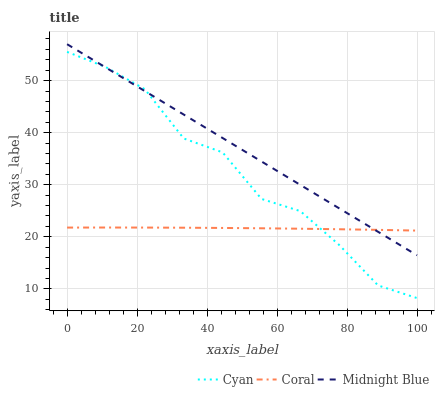Does Coral have the minimum area under the curve?
Answer yes or no. Yes. Does Midnight Blue have the maximum area under the curve?
Answer yes or no. Yes. Does Midnight Blue have the minimum area under the curve?
Answer yes or no. No. Does Coral have the maximum area under the curve?
Answer yes or no. No. Is Midnight Blue the smoothest?
Answer yes or no. Yes. Is Cyan the roughest?
Answer yes or no. Yes. Is Coral the smoothest?
Answer yes or no. No. Is Coral the roughest?
Answer yes or no. No. Does Midnight Blue have the lowest value?
Answer yes or no. No. Does Midnight Blue have the highest value?
Answer yes or no. Yes. Does Coral have the highest value?
Answer yes or no. No. Does Cyan intersect Midnight Blue?
Answer yes or no. Yes. Is Cyan less than Midnight Blue?
Answer yes or no. No. Is Cyan greater than Midnight Blue?
Answer yes or no. No. 